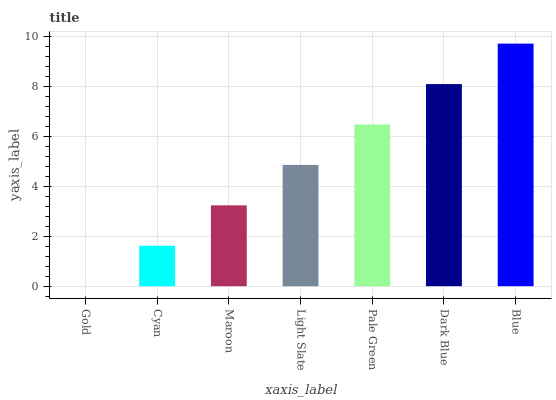Is Gold the minimum?
Answer yes or no. Yes. Is Blue the maximum?
Answer yes or no. Yes. Is Cyan the minimum?
Answer yes or no. No. Is Cyan the maximum?
Answer yes or no. No. Is Cyan greater than Gold?
Answer yes or no. Yes. Is Gold less than Cyan?
Answer yes or no. Yes. Is Gold greater than Cyan?
Answer yes or no. No. Is Cyan less than Gold?
Answer yes or no. No. Is Light Slate the high median?
Answer yes or no. Yes. Is Light Slate the low median?
Answer yes or no. Yes. Is Gold the high median?
Answer yes or no. No. Is Cyan the low median?
Answer yes or no. No. 